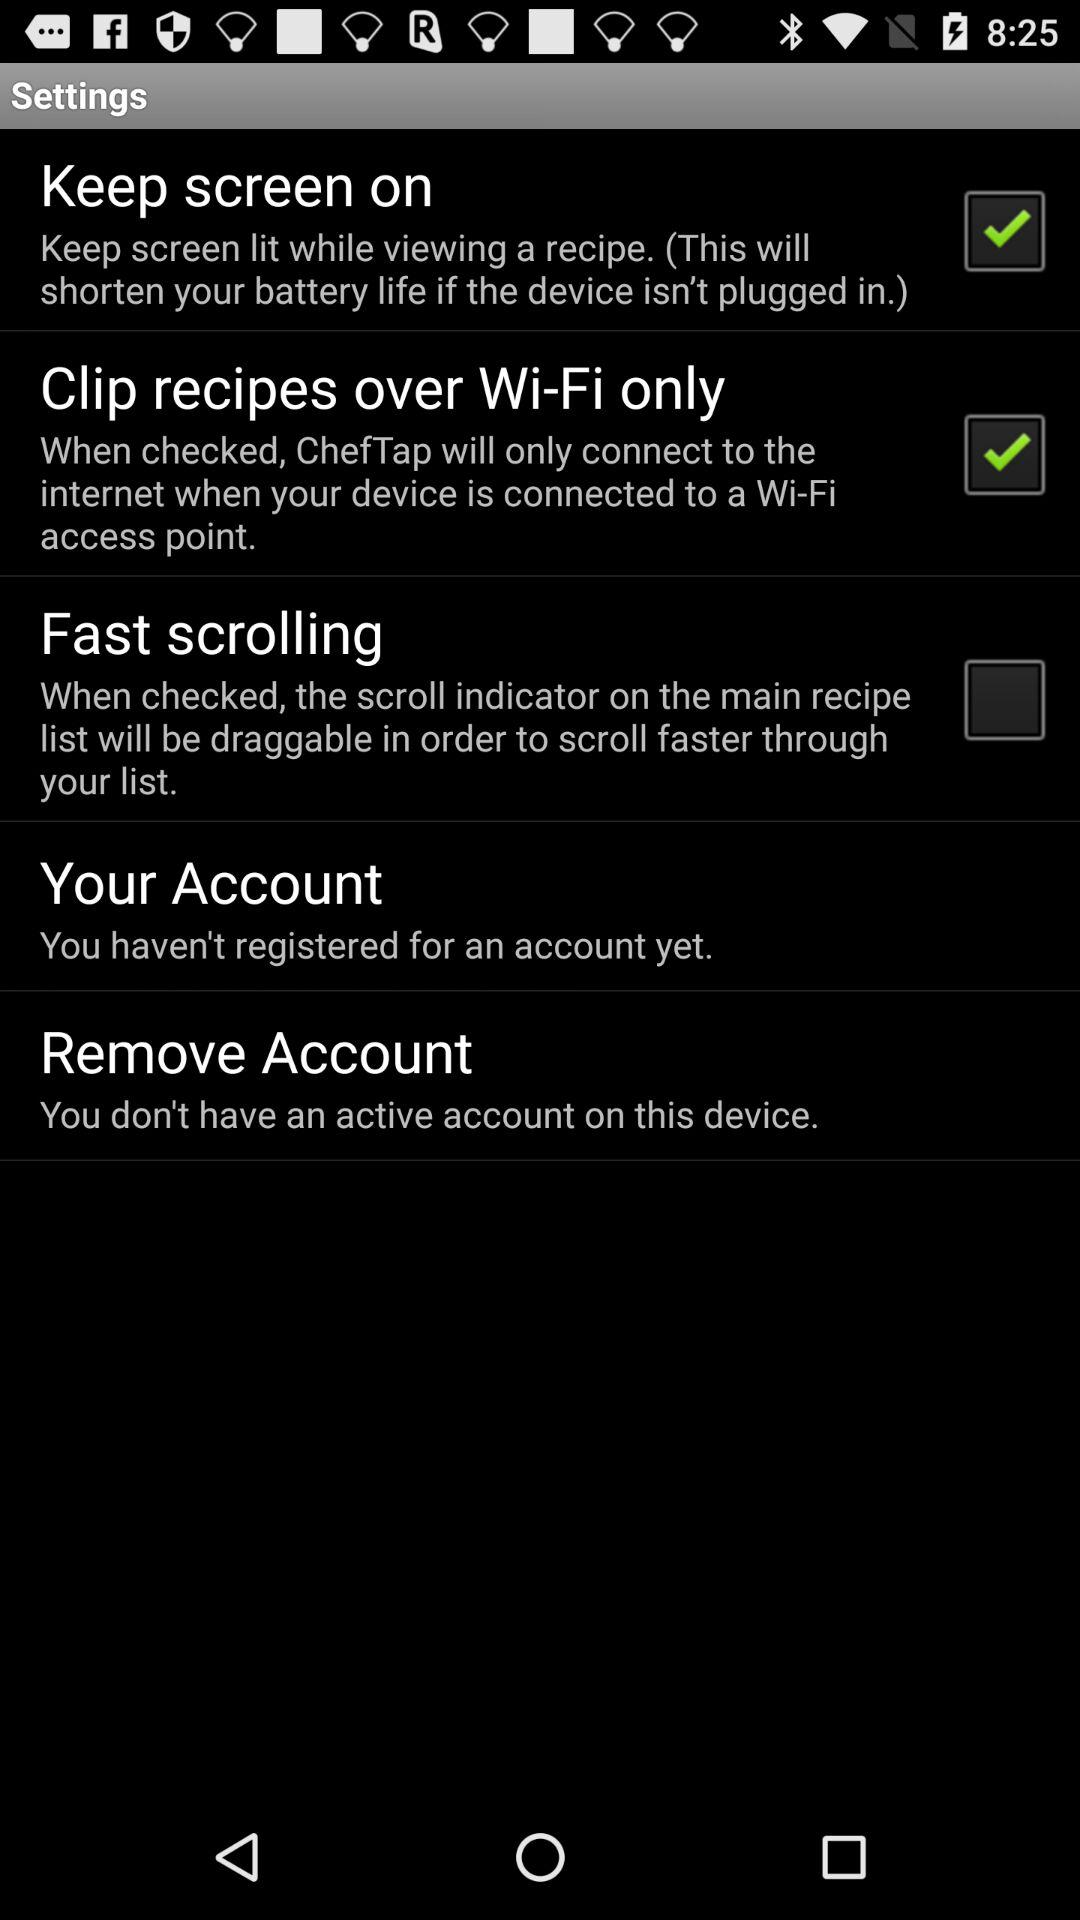What is the current status of fast scrolling? The status is off. 